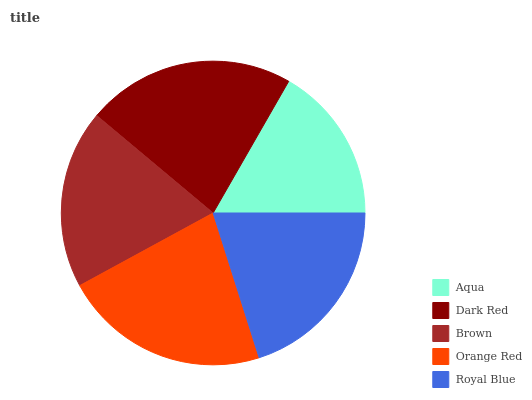Is Aqua the minimum?
Answer yes or no. Yes. Is Dark Red the maximum?
Answer yes or no. Yes. Is Brown the minimum?
Answer yes or no. No. Is Brown the maximum?
Answer yes or no. No. Is Dark Red greater than Brown?
Answer yes or no. Yes. Is Brown less than Dark Red?
Answer yes or no. Yes. Is Brown greater than Dark Red?
Answer yes or no. No. Is Dark Red less than Brown?
Answer yes or no. No. Is Royal Blue the high median?
Answer yes or no. Yes. Is Royal Blue the low median?
Answer yes or no. Yes. Is Dark Red the high median?
Answer yes or no. No. Is Orange Red the low median?
Answer yes or no. No. 